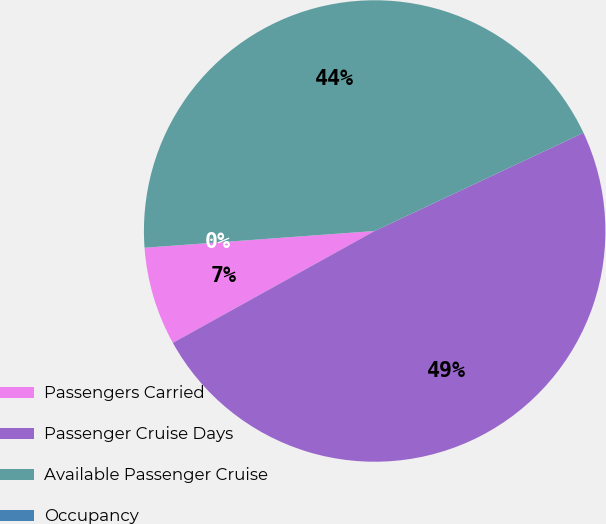Convert chart to OTSL. <chart><loc_0><loc_0><loc_500><loc_500><pie_chart><fcel>Passengers Carried<fcel>Passenger Cruise Days<fcel>Available Passenger Cruise<fcel>Occupancy<nl><fcel>6.9%<fcel>48.94%<fcel>44.16%<fcel>0.0%<nl></chart> 